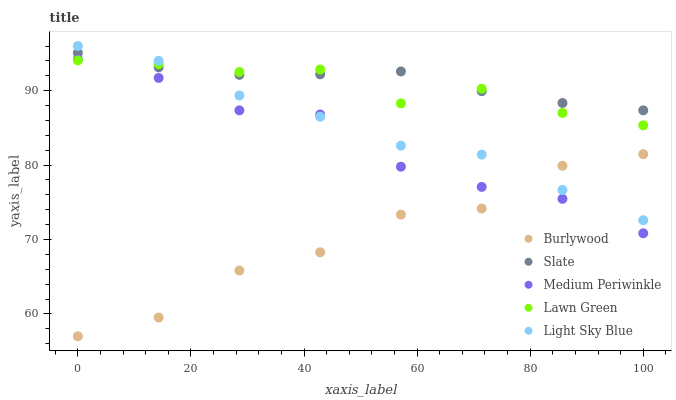Does Burlywood have the minimum area under the curve?
Answer yes or no. Yes. Does Slate have the maximum area under the curve?
Answer yes or no. Yes. Does Lawn Green have the minimum area under the curve?
Answer yes or no. No. Does Lawn Green have the maximum area under the curve?
Answer yes or no. No. Is Slate the smoothest?
Answer yes or no. Yes. Is Burlywood the roughest?
Answer yes or no. Yes. Is Lawn Green the smoothest?
Answer yes or no. No. Is Lawn Green the roughest?
Answer yes or no. No. Does Burlywood have the lowest value?
Answer yes or no. Yes. Does Lawn Green have the lowest value?
Answer yes or no. No. Does Light Sky Blue have the highest value?
Answer yes or no. Yes. Does Lawn Green have the highest value?
Answer yes or no. No. Is Medium Periwinkle less than Slate?
Answer yes or no. Yes. Is Slate greater than Burlywood?
Answer yes or no. Yes. Does Lawn Green intersect Light Sky Blue?
Answer yes or no. Yes. Is Lawn Green less than Light Sky Blue?
Answer yes or no. No. Is Lawn Green greater than Light Sky Blue?
Answer yes or no. No. Does Medium Periwinkle intersect Slate?
Answer yes or no. No. 